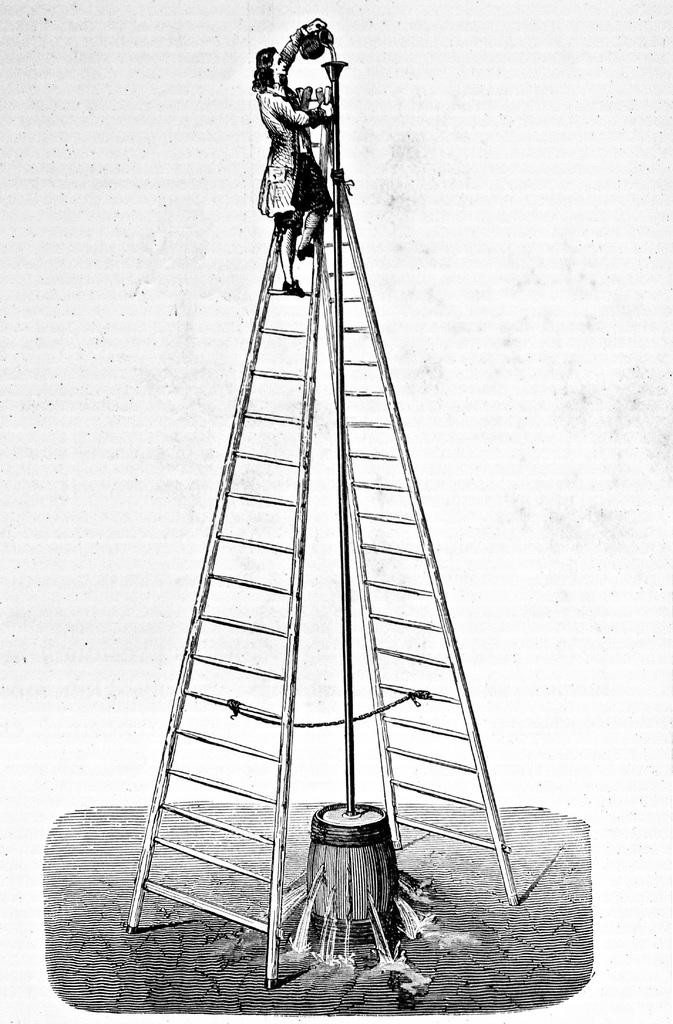What is depicted in the image? There is a drawing of a man in the image. What is the man doing in the drawing? The man is climbing a ladder in the drawing. What object is the man holding in the drawing? The man is holding a mug in the drawing. What other object can be seen in the image? There is a drum in the image. What is the nature of the water visible in the image? The water is visible in the image, but its specific nature or context is not clear from the provided facts. How many ladybugs are crawling on the cactus in the image? There are no ladybugs or cacti present in the image; it features a drawing of a man climbing a ladder and holding a mug, along with a drum and water visible in the image. 